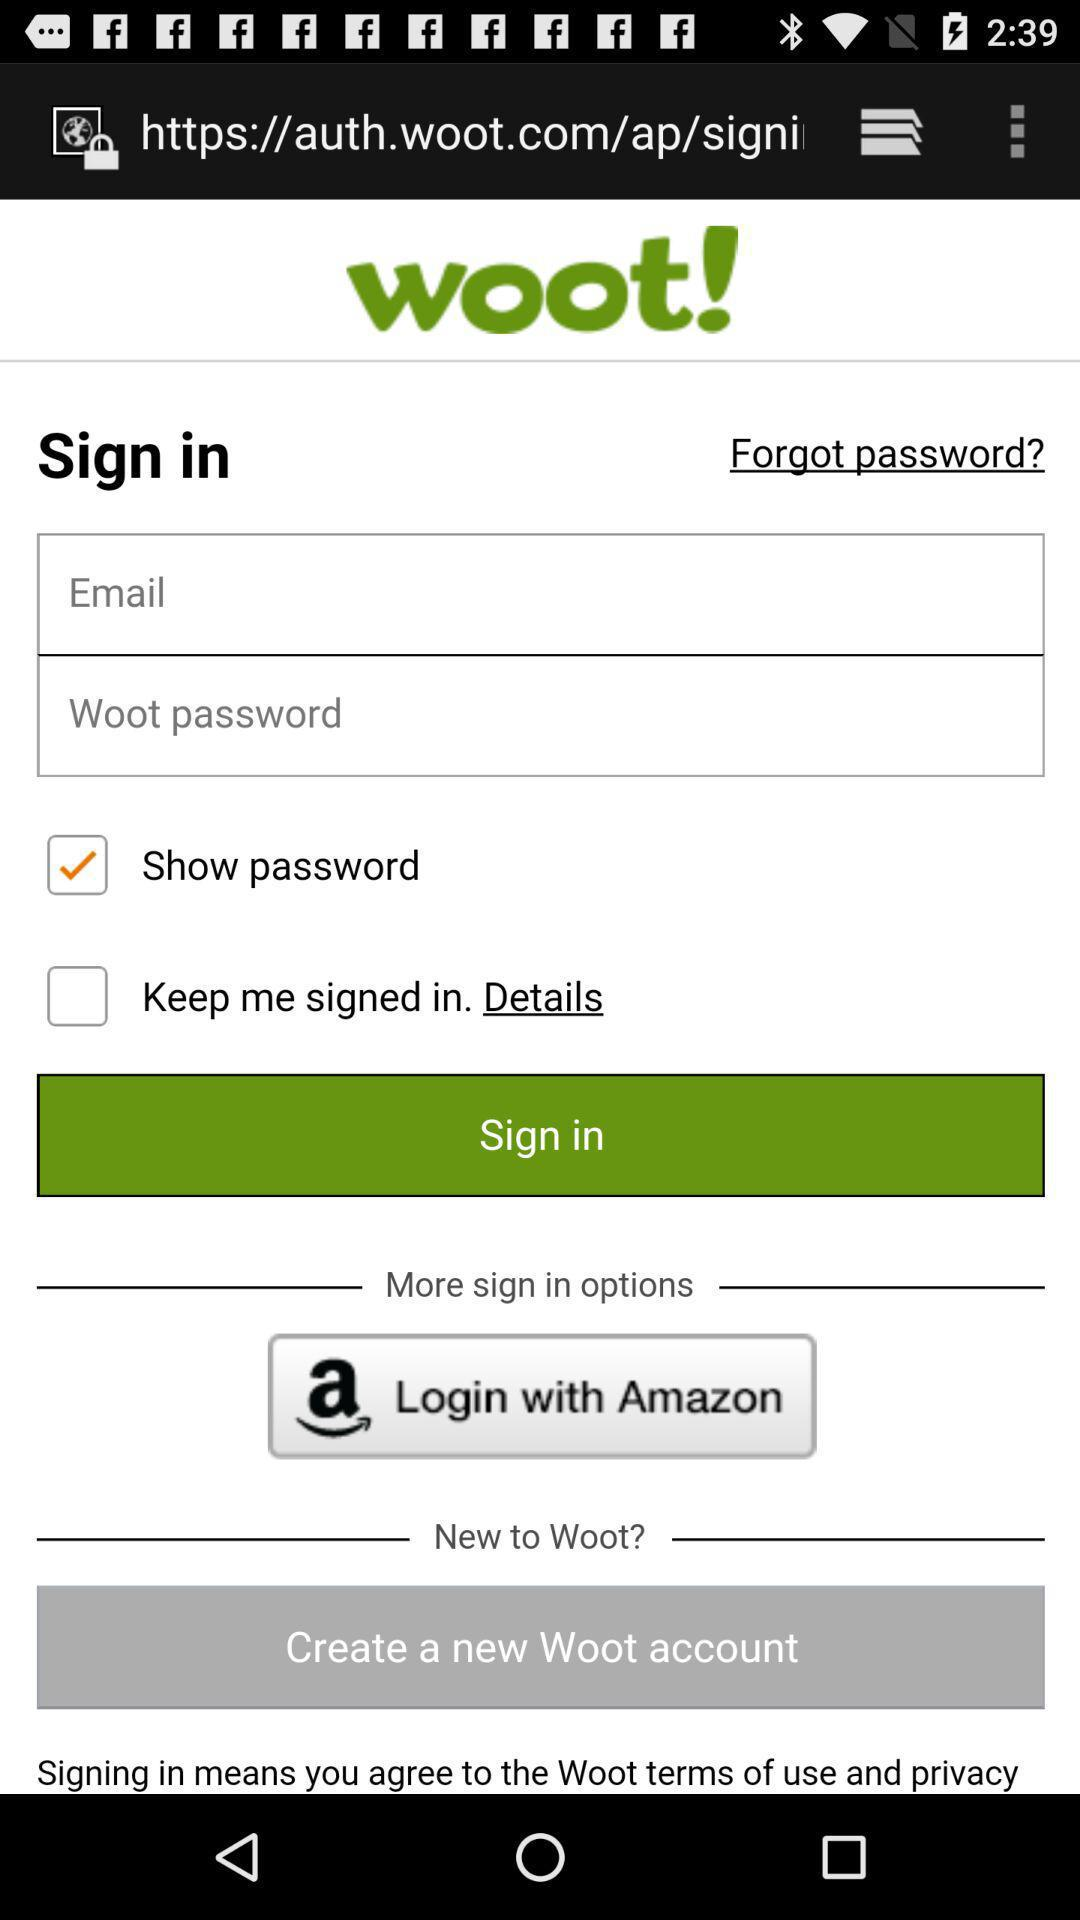What is the status of "Show password"? The status of "Show password" is "on". 